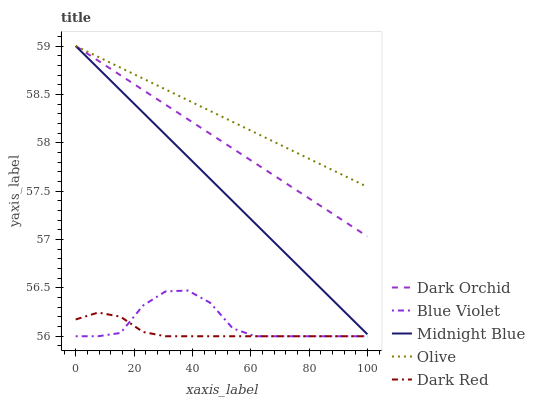Does Blue Violet have the minimum area under the curve?
Answer yes or no. No. Does Blue Violet have the maximum area under the curve?
Answer yes or no. No. Is Dark Red the smoothest?
Answer yes or no. No. Is Dark Red the roughest?
Answer yes or no. No. Does Dark Orchid have the lowest value?
Answer yes or no. No. Does Blue Violet have the highest value?
Answer yes or no. No. Is Blue Violet less than Olive?
Answer yes or no. Yes. Is Olive greater than Blue Violet?
Answer yes or no. Yes. Does Blue Violet intersect Olive?
Answer yes or no. No. 